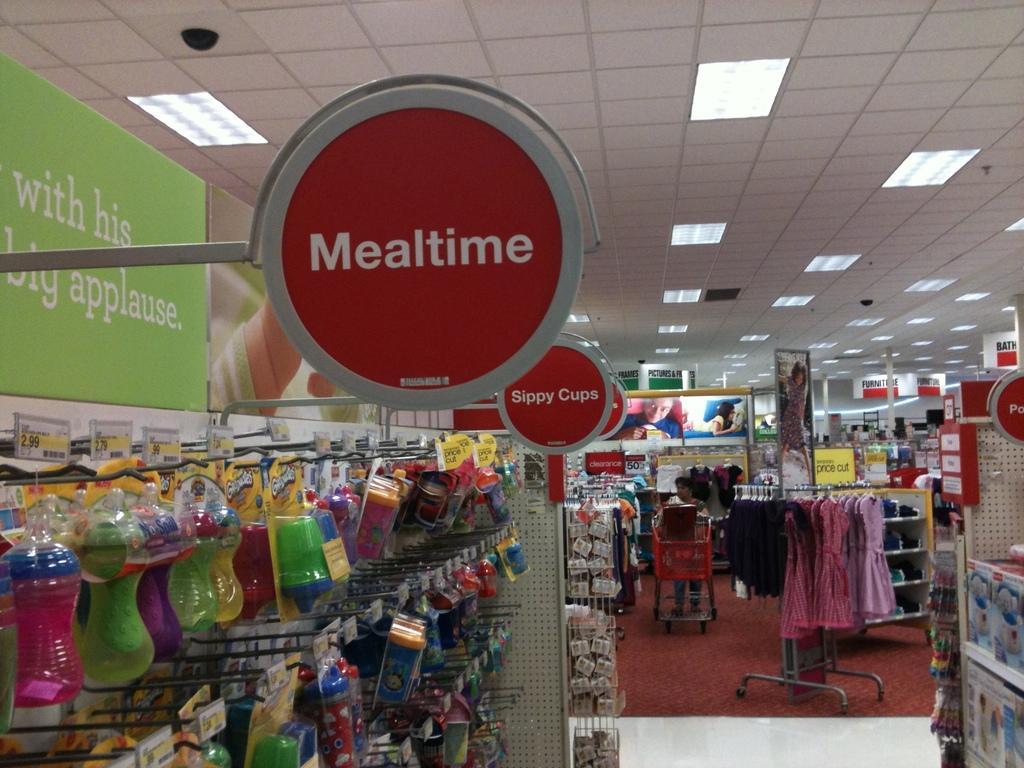How would you summarize this image in a sentence or two? This image is taken from inside the stall. In this image there are bottles, dresses and other objects arranged in racks, there are few sign boards with some text on it. At the top of the image there is a ceiling with lights. 